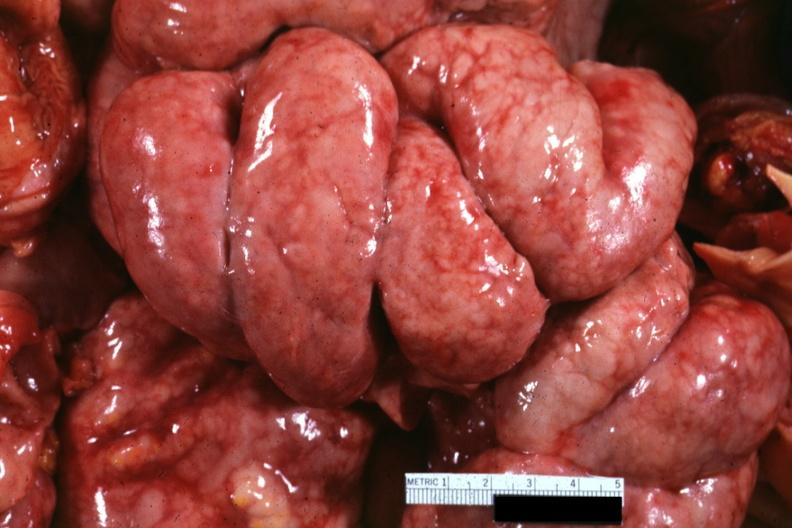where is this area in the body?
Answer the question using a single word or phrase. Abdomen 